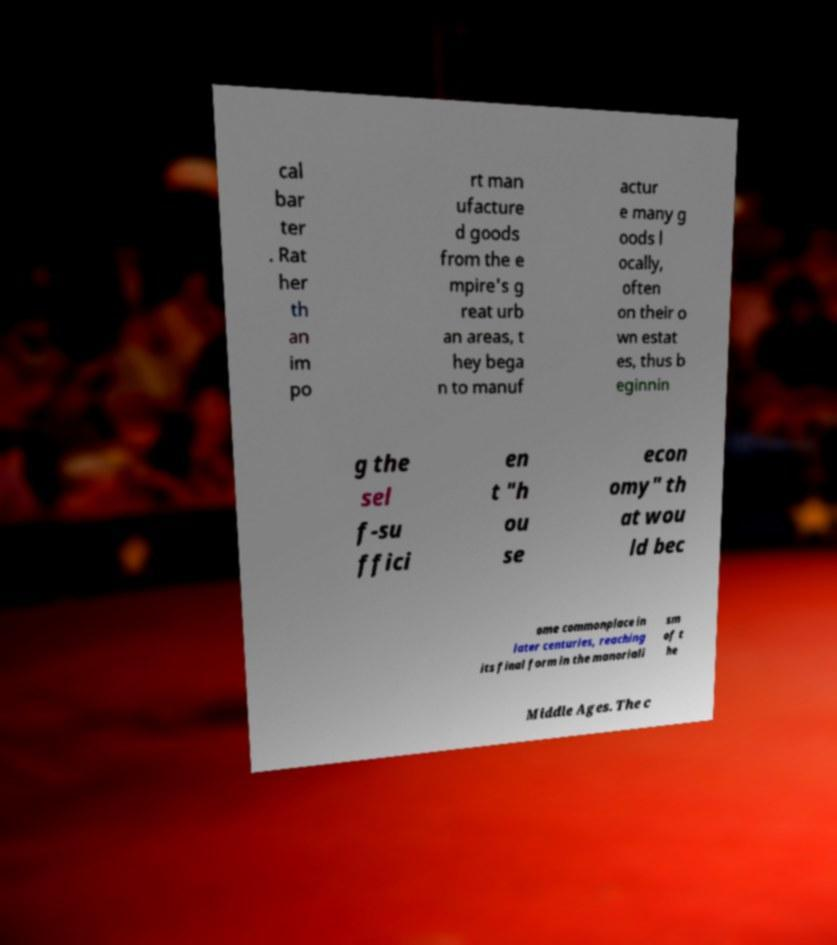Please identify and transcribe the text found in this image. cal bar ter . Rat her th an im po rt man ufacture d goods from the e mpire's g reat urb an areas, t hey bega n to manuf actur e many g oods l ocally, often on their o wn estat es, thus b eginnin g the sel f-su ffici en t "h ou se econ omy" th at wou ld bec ome commonplace in later centuries, reaching its final form in the manoriali sm of t he Middle Ages. The c 